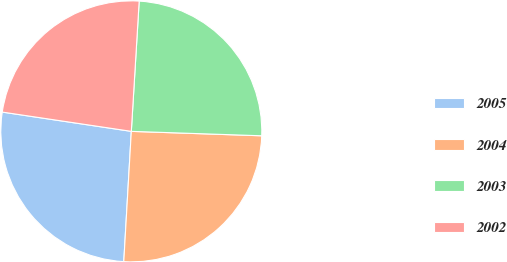Convert chart. <chart><loc_0><loc_0><loc_500><loc_500><pie_chart><fcel>2005<fcel>2004<fcel>2003<fcel>2002<nl><fcel>26.44%<fcel>25.38%<fcel>24.58%<fcel>23.6%<nl></chart> 